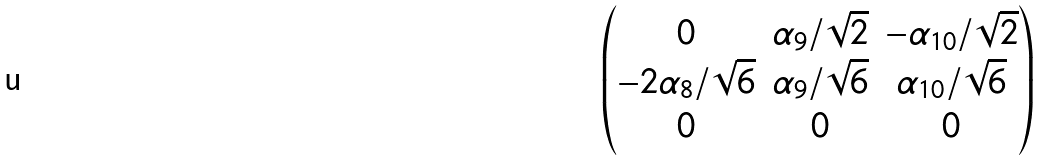Convert formula to latex. <formula><loc_0><loc_0><loc_500><loc_500>\begin{pmatrix} 0 & \alpha _ { 9 } / \sqrt { 2 } & - \alpha _ { 1 0 } / \sqrt { 2 } \\ - 2 \alpha _ { 8 } / \sqrt { 6 } & \alpha _ { 9 } / \sqrt { 6 } & \alpha _ { 1 0 } / \sqrt { 6 } \\ 0 & 0 & 0 \\ \end{pmatrix}</formula> 